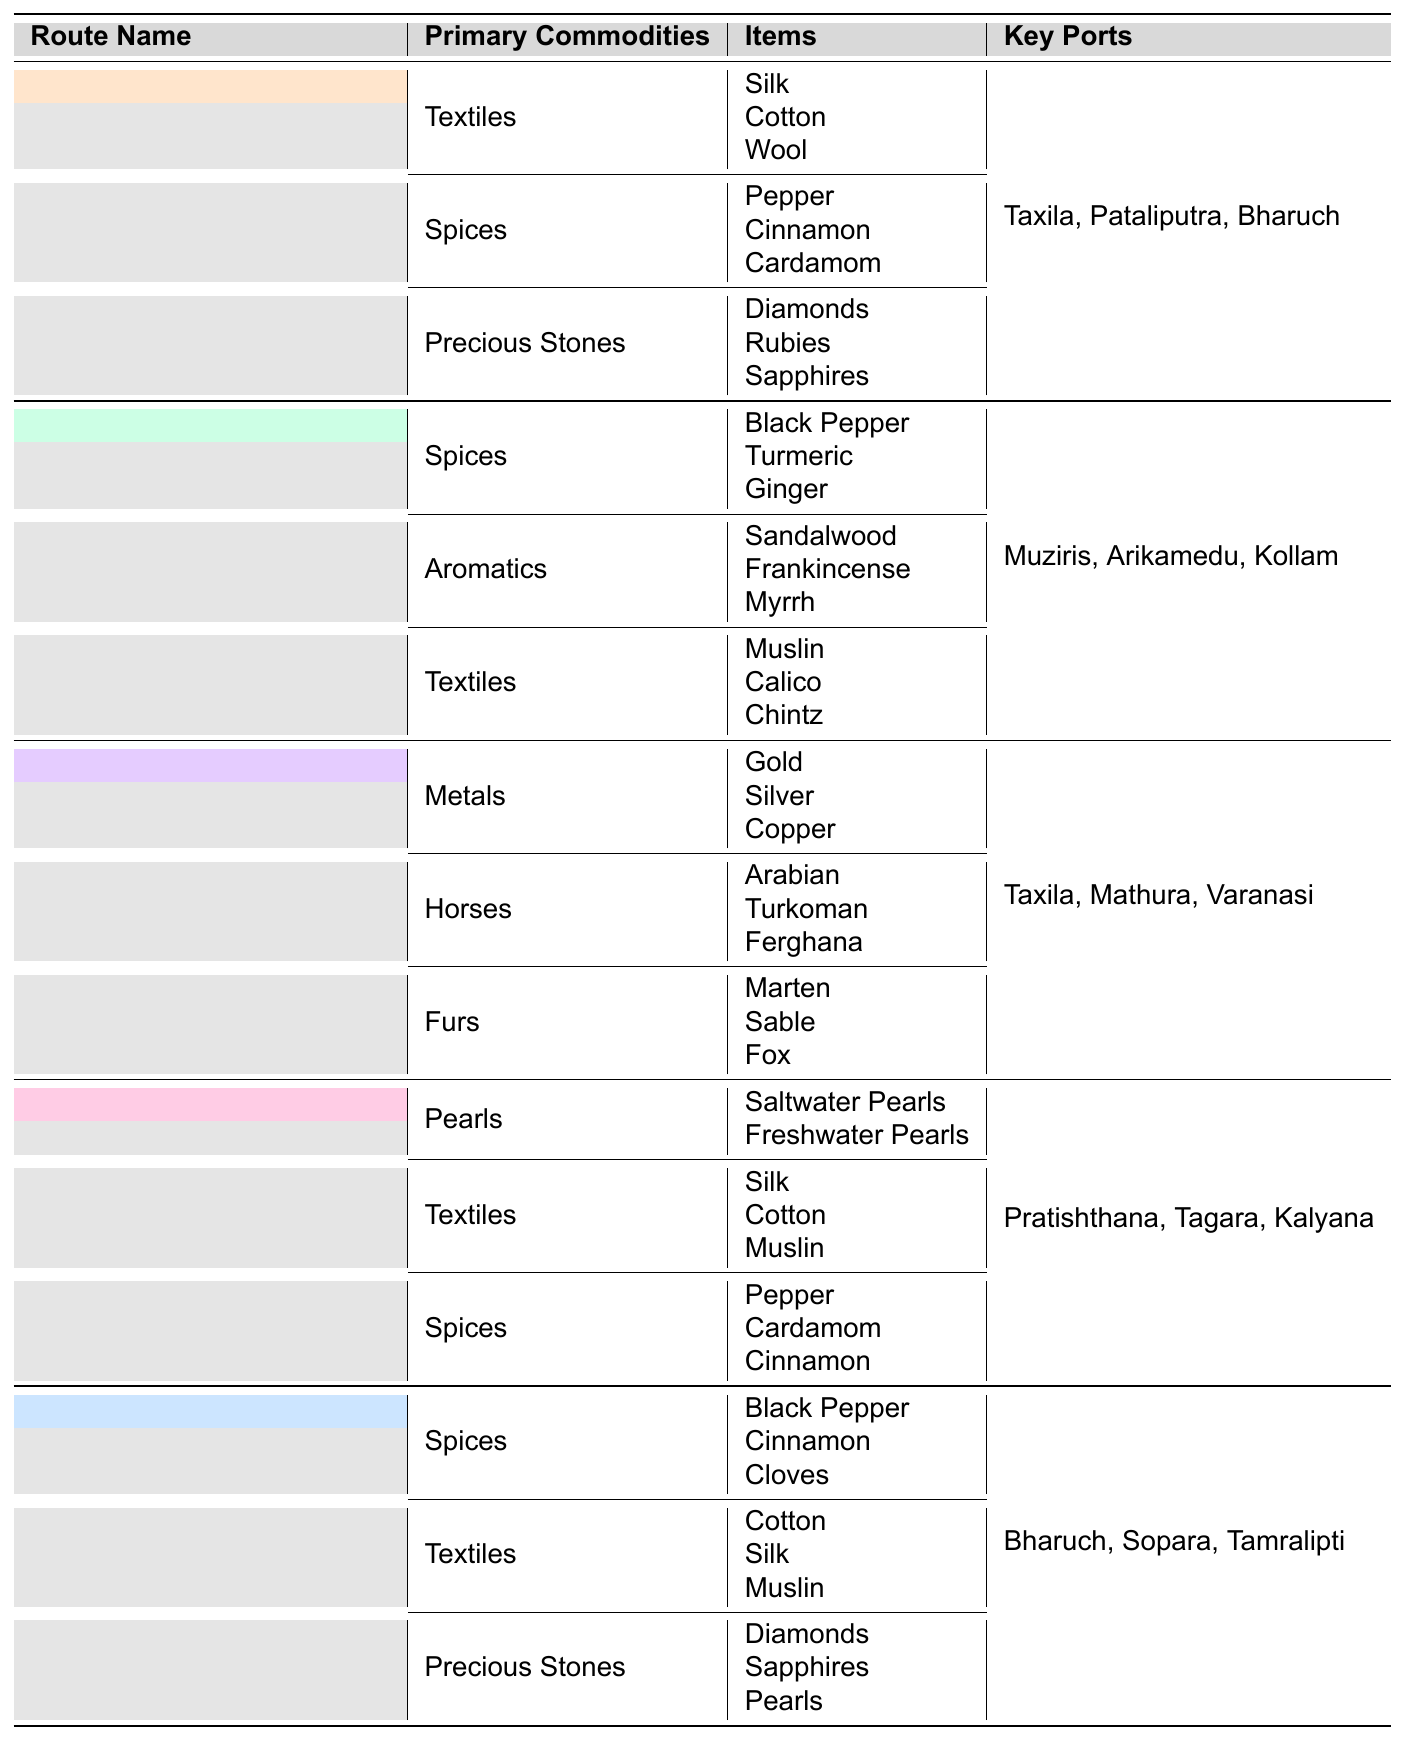What are the key ports for the Silk Road? The table lists the key ports for the Silk Road under the corresponding route name. The key ports mentioned are Taxila, Pataliputra, and Bharuch.
Answer: Taxila, Pataliputra, Bharuch Which route has the commodity category of Furs? By examining the table, the Uttarapatha route has the commodity category described as Furs, which includes items like Marten, Sable, and Fox.
Answer: Uttarapatha How many different categories of primary commodities are there for the Spice Route? The Spice Route has three distinct categories of primary commodities according to the table: Spices, Aromatics, and Textiles.
Answer: 3 True or False: The Indian Ocean Maritime Route includes Gold among its primary commodities. The table does not list Gold under any commodities for the Indian Ocean Maritime Route, which instead includes Spices, Textiles, and Precious Stones.
Answer: False Which route has the most key ports listed? Upon reviewing the table, both the Silk Road and the Indian Ocean Maritime Route have three key ports listed each (Taxila, Pataliputra, Bharuch for Silk Road and Bharuch, Sopara, Tamralipti for Indian Ocean Maritime Route), making them tied for the most.
Answer: Silk Road and Indian Ocean Maritime Route (both have 3 key ports) What is the total number of items under the Spices category in the Dakshinapatha route? Looking at the table, the Dakshinapatha route has three items in the Spices category: Pepper, Cardamom, and Cinnamon. Therefore, the total number of items under the Spices category for this route is three.
Answer: 3 If we combine all the primary commodities from the Uttarapatha and Dakshinapatha routes, how many unique categories do we get? The Uttarapatha has Metals, Horses, and Furs, while Dakshinapatha has Pearls, Textiles, and Spices. There are a total of 6 unique categories when we combine both routes.
Answer: 6 Which route includes both Diamonds and Rubies among its commodities? The table indicates that both Diamonds and Rubies are found under the Precious Stones category for the Silk Road route.
Answer: Silk Road Are there more categories of commodities focusing on Spices or Textiles in the table? Counting the categories, the table shows that both the Silk Road and Indian Ocean Maritime Route focus on Spices (4 categories), while the Spice Route and Dakshinapatha emphasize Textiles (3 categories). Thus, Spices has more categories.
Answer: Spices Which item is listed as a commodity under the category of Precious Stones? The items listed under the Precious Stones category are Diamonds, Rubies, and Sapphires according to the table.
Answer: Diamonds, Rubies, Sapphires What is the total number of primary commodities listed for the Spice Route? The Spice Route features three distinct categories of primary commodities: Spices, Aromatics, and Textiles. Each category contains three items, hence the total count remains three.
Answer: 3 